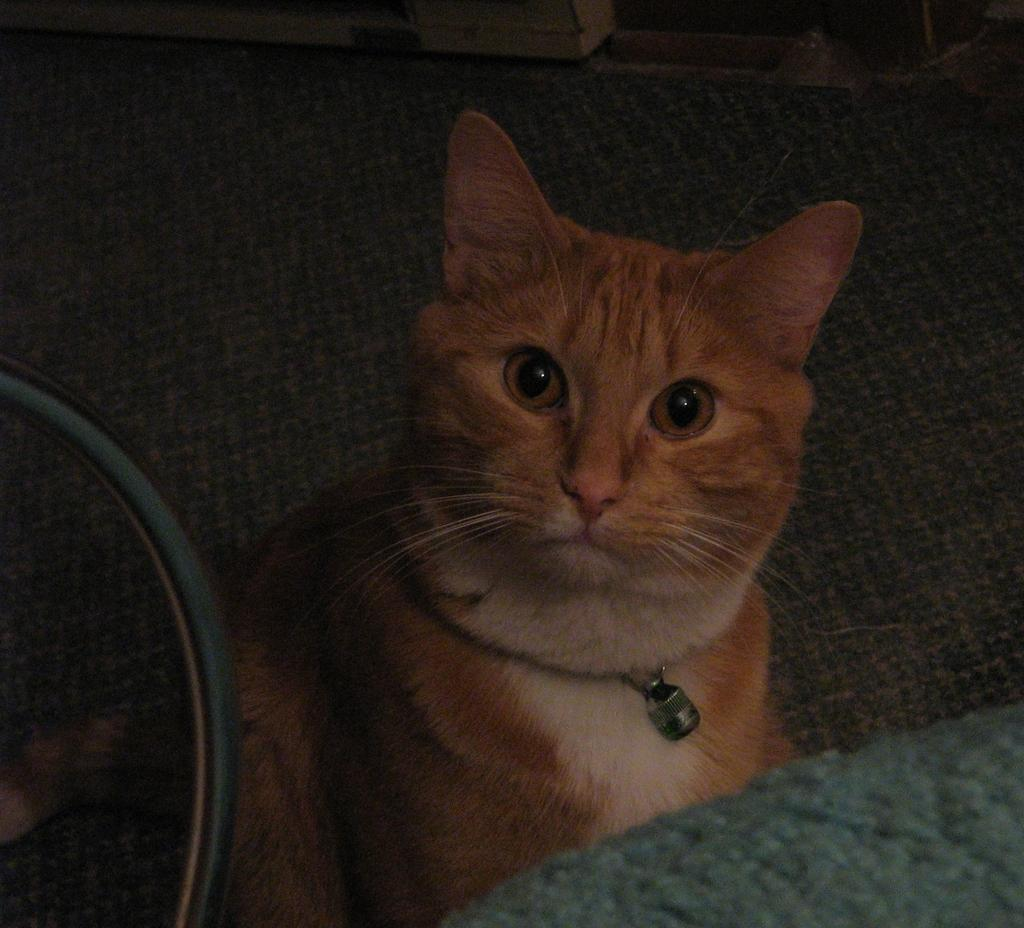What type of animal is on the sofa in the image? There is a cat on the sofa in the image. What piece of furniture is visible in the image? There is a table in the image. What is the unidentified object in the image? There is an object in the image. What type of jam is the cat spreading on the lip in the image? There is no jam, lip, or any activity involving spreading in the image; it features a cat on a sofa and a table. 